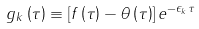Convert formula to latex. <formula><loc_0><loc_0><loc_500><loc_500>g _ { k } \left ( \tau \right ) \equiv \left [ f \left ( \tau \right ) - \theta \left ( \tau \right ) \right ] e ^ { - \epsilon _ { k } \tau }</formula> 